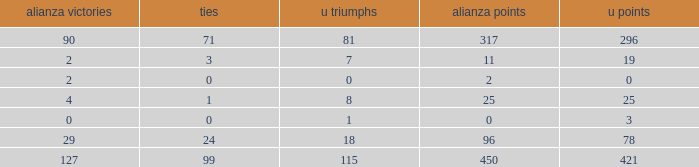What is the lowest U Wins, when Alianza Wins is greater than 0, when Alianza Goals is greater than 25, and when Draws is "99"? 115.0. 